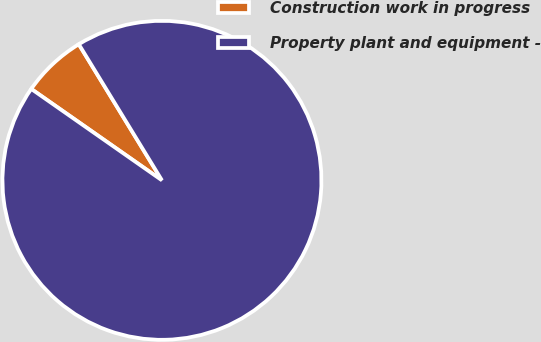<chart> <loc_0><loc_0><loc_500><loc_500><pie_chart><fcel>Construction work in progress<fcel>Property plant and equipment -<nl><fcel>6.56%<fcel>93.44%<nl></chart> 